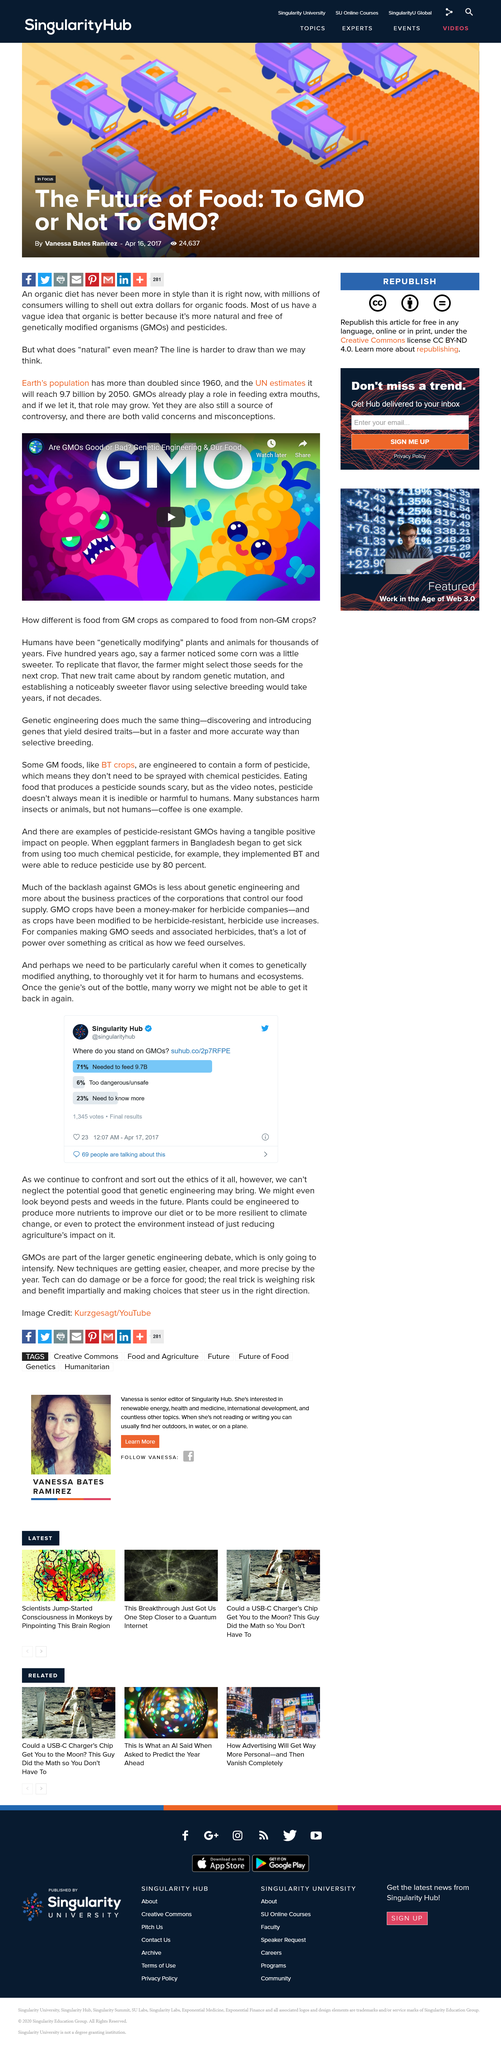Specify some key components in this picture. Yes, it is possible to engineer plants to produce more nutrients. Some consumers are willing to pay extra for organic foods because they believe that organic products are healthier and free from genetically modified organisms and pesticides, making them more natural and superior in quality. A recent survey found that only 23% of voters believed they needed to know more about GMOs. The term "natural" is difficult to define due to the growing demand for GMOs and the increasing population, which has led to GMOs becoming a source of controversy, with valid concerns and misconceptions. In the poll, 6% of voters believed that GMOs were too dangerous and unsafe. 